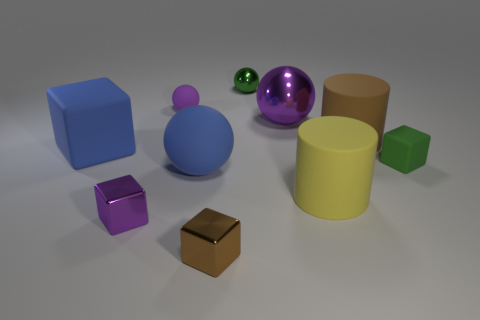How big is the purple cube?
Your answer should be compact. Small. What number of other things are there of the same color as the big rubber cube?
Make the answer very short. 1. Does the purple metallic thing on the left side of the green shiny object have the same shape as the green rubber thing?
Keep it short and to the point. Yes. What color is the other object that is the same shape as the big brown rubber thing?
Offer a terse response. Yellow. Are there any other things that are made of the same material as the large purple thing?
Your answer should be very brief. Yes. The blue object that is the same shape as the purple rubber object is what size?
Your answer should be compact. Large. There is a sphere that is in front of the purple rubber thing and to the right of the brown block; what material is it?
Offer a very short reply. Metal. Is the color of the small cube behind the large yellow cylinder the same as the big rubber block?
Your answer should be very brief. No. There is a large cube; is its color the same as the tiny rubber thing that is behind the big metal thing?
Make the answer very short. No. Are there any shiny objects behind the tiny purple shiny block?
Your response must be concise. Yes. 